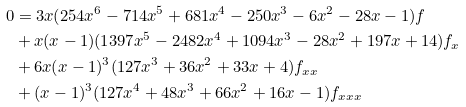Convert formula to latex. <formula><loc_0><loc_0><loc_500><loc_500>0 & = 3 x ( 2 5 4 x ^ { 6 } - 7 1 4 x ^ { 5 } + 6 8 1 x ^ { 4 } - 2 5 0 x ^ { 3 } - 6 x ^ { 2 } - 2 8 x - 1 ) f \\ & + x ( x - 1 ) ( 1 3 9 7 x ^ { 5 } - 2 4 8 2 x ^ { 4 } + 1 0 9 4 x ^ { 3 } - 2 8 x ^ { 2 } + 1 9 7 x + 1 4 ) f _ { x } \\ & + 6 x ( x - 1 ) ^ { 3 } ( 1 2 7 x ^ { 3 } + 3 6 x ^ { 2 } + 3 3 x + 4 ) f _ { x x } \\ & + ( x - 1 ) ^ { 3 } ( 1 2 7 x ^ { 4 } + 4 8 x ^ { 3 } + 6 6 x ^ { 2 } + 1 6 x - 1 ) f _ { x x x }</formula> 